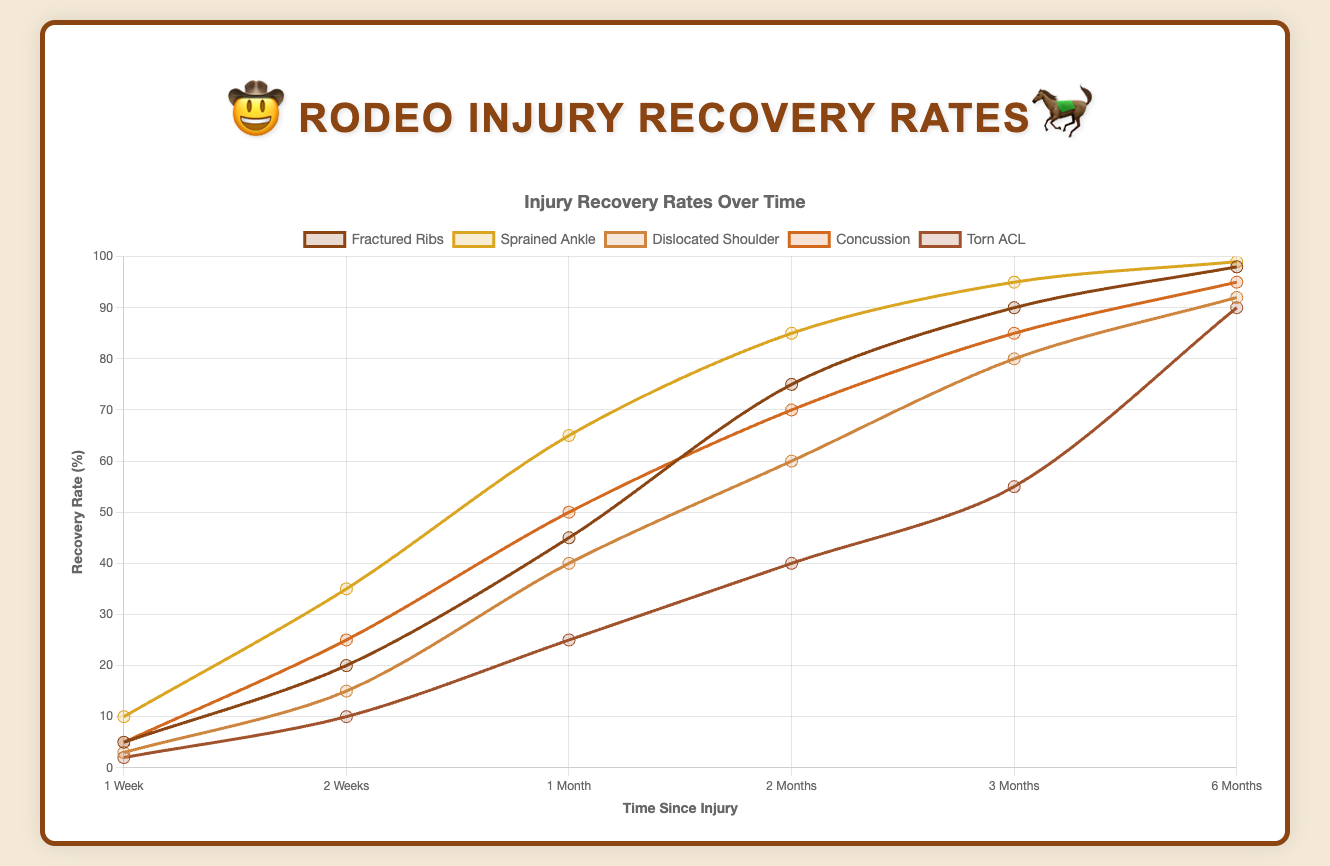Which injury type has the fastest recovery rate within 1 month? By examining the 1-month point on the x-axis for all injury types, the corresponding recovery rate for "Sprained Ankle" is the highest at 65%.
Answer: Sprained Ankle How much does the recovery rate of a dislocated shoulder increase from 1 week to 3 months? The recovery rate for "Dislocated Shoulder" at 1 week is 3%, and at 3 months, it is 80%. The increase is 80% - 3% = 77%.
Answer: 77% Which injury type shows the least improvement in recovery rate between 2 months and 3 months? By comparing the recovery rates for 2 months and 3 months for each injury type, "Fractured Ribs" shows an increase from 75% to 90%, which is a 15% improvement. This is the smallest increase.
Answer: Fractured Ribs What is the average recovery rate for a concussion over 6 months? The recovery rates at various durations for "Concussion" are 5%, 25%, 50%, 70%, 85%, and 95%. The sum is 5 + 25 + 50 + 70 + 85 + 95 = 330. The average is 330 / 6 = 55%.
Answer: 55% Which injury type has the lowest recovery rate at 6 months? Viewing the 6-month point for all injury types, "Torn ACL" has the lowest recovery rate at 90%.
Answer: Torn ACL Compare the recovery rate of a sprained ankle versus a dislocated shoulder at 1 month. Which is higher and by how much? The recovery rate for "Sprained Ankle" at 1 month is 65%, and for "Dislocated Shoulder," it is 40%. The difference is 65% - 40% = 25%.
Answer: Sprained Ankle by 25% On average, how much does the recovery rate for torn ACL increase each month over 3 months? The recovery rates for "Torn ACL" at 1 week, 2 weeks, 1 month, 2 months, and 3 months are 2%, 10%, 25%, 40%, and 55%. Exclude the 1 week and 2 weeks points for a clear monthly increase. Over 3 months, this gives us 25%, 40%, 55%. The average monthly increase is (25 - 10) + (40 - 25) + (55 - 40) = 15% / 3 months = 15%.
Answer: 15% Which injury type surpasses a 50% recovery rate first? Looking at the recovery rates across all durations, the "Sprained Ankle" surpasses 50% by 1 month with a recovery rate of 65%.
Answer: Sprained Ankle At 2 months, which injury types have a recovery rate greater than 70%? The recovery rates for 2 months are compared for each injury type. "Fractured Ribs" (75%), "Sprained Ankle" (85%), and "Concussion" (70%) all have recovery rates greater than 70%.
Answer: Fractured Ribs, Sprained Ankle, Concussion Over a duration of 6 months, which injury type shows the highest improvement in recovery rate? The initial and final recovery rates for each injury type are considered. "Fractured Ribs" improves from 5% to 98% (93%), "Sprained Ankle" from 10% to 99% (89%), "Dislocated Shoulder" from 3% to 92% (89%), "Concussion" from 5% to 95% (90%), "Torn ACL" from 2% to 90% (88%). "Fractured Ribs" has the highest improvement of 93%.
Answer: Fractured Ribs 